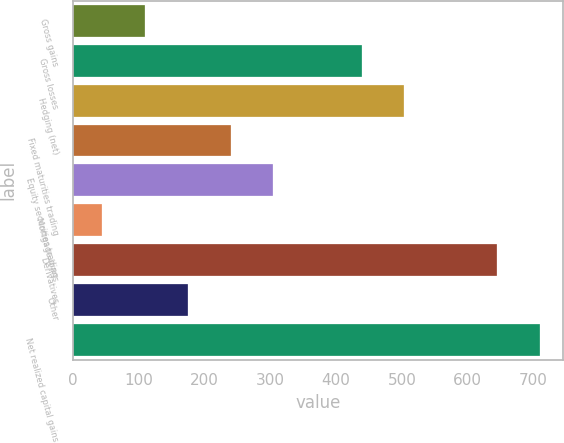Convert chart to OTSL. <chart><loc_0><loc_0><loc_500><loc_500><bar_chart><fcel>Gross gains<fcel>Gross losses<fcel>Hedging (net)<fcel>Fixed maturities trading<fcel>Equity securities trading<fcel>Mortgage loans<fcel>Derivatives<fcel>Other<fcel>Net realized capital gains<nl><fcel>109.73<fcel>438.7<fcel>503.63<fcel>239.59<fcel>304.52<fcel>44.8<fcel>645.1<fcel>174.66<fcel>710.03<nl></chart> 